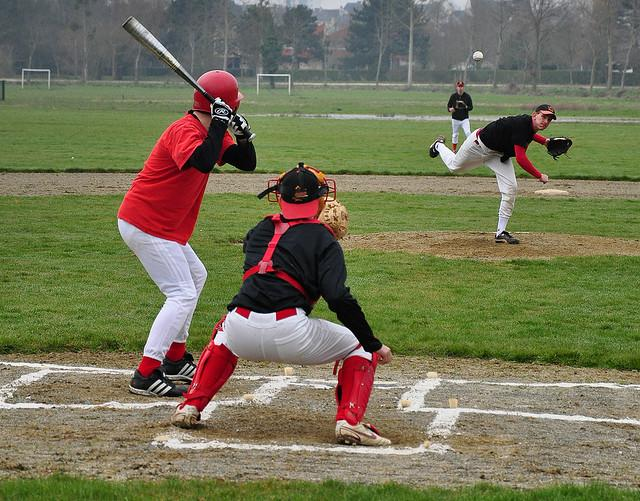What time of the year is it? Please explain your reasoning. winter. The players are dressed warmly and many of the trees in the background have no leaves. in winter, the trees have often lost their leaves and the weather is frequently cold causing people to dress warmly. 